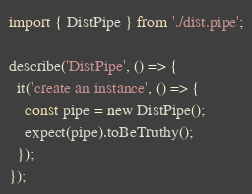<code> <loc_0><loc_0><loc_500><loc_500><_TypeScript_>import { DistPipe } from './dist.pipe';

describe('DistPipe', () => {
  it('create an instance', () => {
    const pipe = new DistPipe();
    expect(pipe).toBeTruthy();
  });
});
</code> 